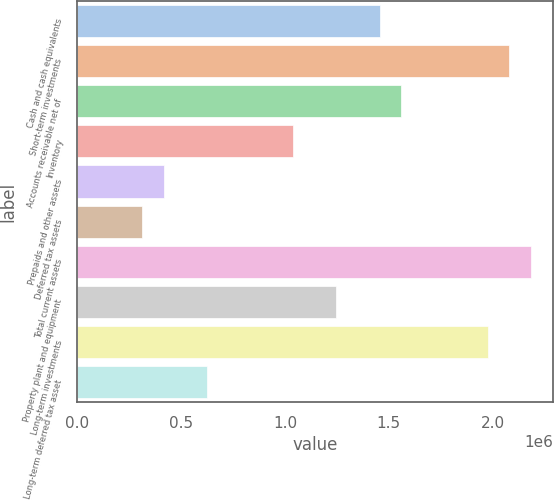Convert chart to OTSL. <chart><loc_0><loc_0><loc_500><loc_500><bar_chart><fcel>Cash and cash equivalents<fcel>Short-term investments<fcel>Accounts receivable net of<fcel>Inventory<fcel>Prepaids and other assets<fcel>Deferred tax assets<fcel>Total current assets<fcel>Property plant and equipment<fcel>Long-term investments<fcel>Long-term deferred tax asset<nl><fcel>1.45598e+06<fcel>2.07996e+06<fcel>1.55998e+06<fcel>1.04e+06<fcel>416022<fcel>312026<fcel>2.18395e+06<fcel>1.24799e+06<fcel>1.97596e+06<fcel>624014<nl></chart> 